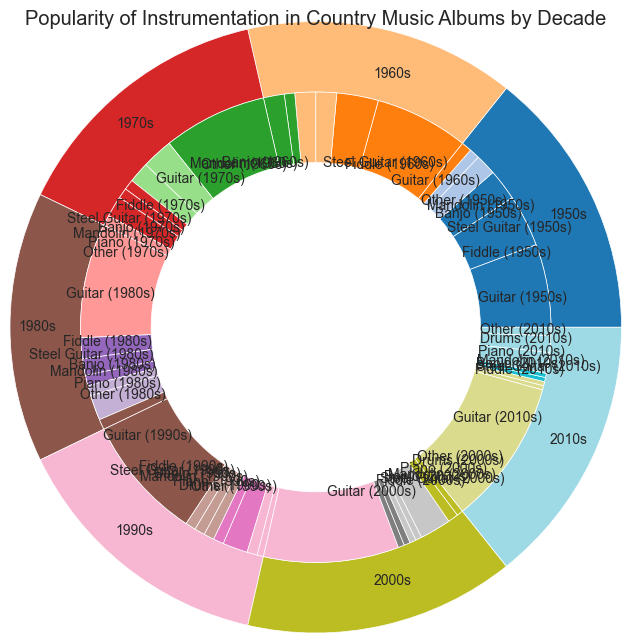Which decade has the highest overall popularity of the guitar? The figure shows that the guitar's popularity increases each decade. By comparing the labeled percentages for the guitar across all decades, the 2010s show the highest at 70%.
Answer: 2010s What is the percentage difference in fiddle popularity between the 1950s and the 2010s? By examining the figure, the figure shows the fiddle accounted for 25% of the 1950s, while it only accounts for 2% in the 2010s. The difference can be calculated as 25% - 2% = 23%.
Answer: 23% Which decade introduced the piano as a popular instrument in country music albums? The visual shows the first appearance of the "Piano" label is in the inner ring for the 1970s.
Answer: 1970s How does the popularity of the drums in the 1990s compare to their popularity in the 2010s? In the 1990s segment of the figure, the drums are given 5%, whereas in the 2010s, they are part of the segment with 8%. 8% - 5% = 3% more popular in the 2010s.
Answer: 3% more popular in the 2010s What is the total percentage share of "Other" instruments in the 1960s and 1970s combined? The segment for "Other" instruments shows 10% in the 1960s and 5% in the 1970s. The total is calculated as 10% + 5% = 15%.
Answer: 15% Compare the popularity of the steel guitar in the 1980s with the 2000s. Which decade had a higher percentage? By looking at the labeled percentages, the steel guitar had 8% popularity in the 1980s and only 3% in the 2000s. Thus, it was more popular in the 1980s.
Answer: 1980s Which instrument’s popularity remained constant from the 1950s to the 1970s? The segment showing the percentages of each instrument between decades indicates that the "Mandolin" remains the same at 5% from the 1950s through the 1960s to the 1970s.
Answer: Mandolin How did the popularity of the banjo change from the 1950s to the 2010s? The figure shows the Banjo at 10% in the 1950s and decreases step by step through each decade, ending up at 2% in the 2010s. Calculate each step decrease: 10% (1950s) → 10% (1960s) → 5% (1970s) → 5% (1980s) → 5% (1990s) → 3% (2000s) → 2% (2010s). Ultimately, the total decrease is 10% - 2% = 8%.
Answer: Decreased by 8% 